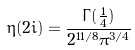<formula> <loc_0><loc_0><loc_500><loc_500>\eta ( 2 i ) = \frac { \Gamma ( \frac { 1 } { 4 } ) } { 2 ^ { 1 1 / 8 } \pi ^ { 3 / 4 } }</formula> 